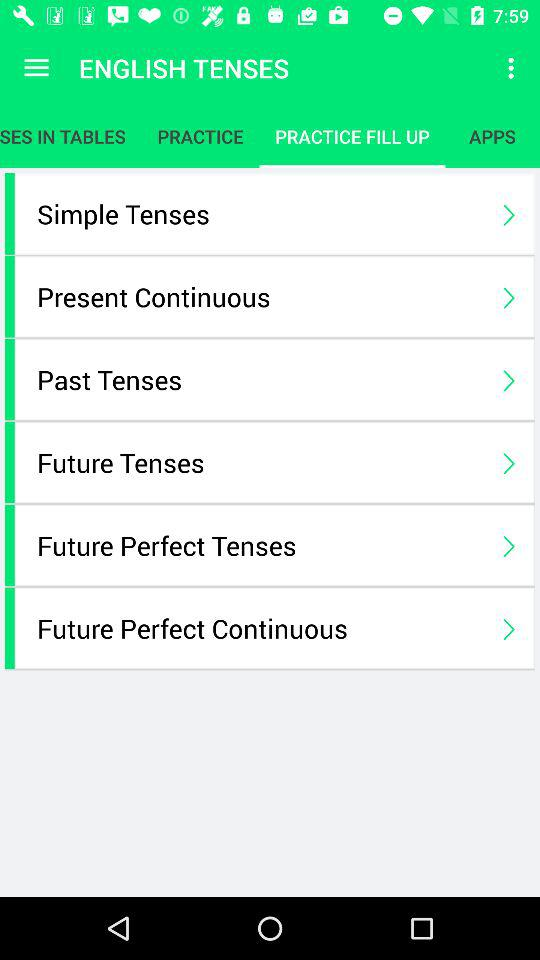What is the application name? The application name is "ENGLISH TENSES". 